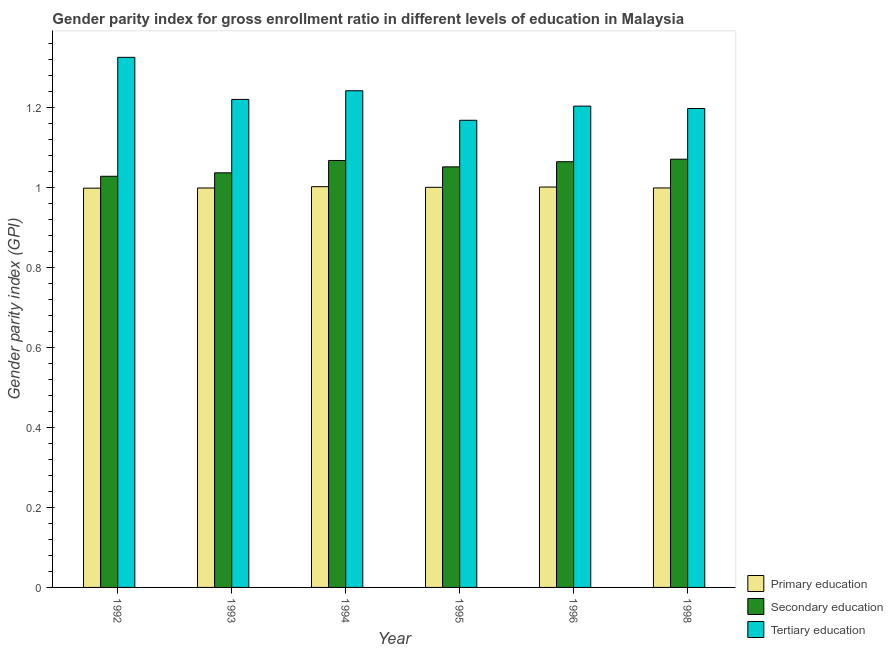How many different coloured bars are there?
Your response must be concise. 3. Are the number of bars per tick equal to the number of legend labels?
Offer a very short reply. Yes. Are the number of bars on each tick of the X-axis equal?
Offer a very short reply. Yes. How many bars are there on the 5th tick from the right?
Your answer should be compact. 3. What is the label of the 5th group of bars from the left?
Make the answer very short. 1996. In how many cases, is the number of bars for a given year not equal to the number of legend labels?
Give a very brief answer. 0. What is the gender parity index in secondary education in 1994?
Give a very brief answer. 1.07. Across all years, what is the maximum gender parity index in tertiary education?
Offer a terse response. 1.33. Across all years, what is the minimum gender parity index in primary education?
Your answer should be very brief. 1. In which year was the gender parity index in secondary education minimum?
Make the answer very short. 1992. What is the total gender parity index in secondary education in the graph?
Your answer should be compact. 6.32. What is the difference between the gender parity index in tertiary education in 1992 and that in 1996?
Your answer should be very brief. 0.12. What is the difference between the gender parity index in primary education in 1998 and the gender parity index in secondary education in 1995?
Your answer should be compact. -0. What is the average gender parity index in tertiary education per year?
Keep it short and to the point. 1.23. In the year 1992, what is the difference between the gender parity index in primary education and gender parity index in secondary education?
Offer a terse response. 0. In how many years, is the gender parity index in primary education greater than 0.8400000000000001?
Offer a terse response. 6. What is the ratio of the gender parity index in secondary education in 1992 to that in 1996?
Give a very brief answer. 0.97. Is the difference between the gender parity index in tertiary education in 1993 and 1995 greater than the difference between the gender parity index in secondary education in 1993 and 1995?
Ensure brevity in your answer.  No. What is the difference between the highest and the second highest gender parity index in secondary education?
Provide a short and direct response. 0. What is the difference between the highest and the lowest gender parity index in tertiary education?
Your answer should be very brief. 0.16. What does the 1st bar from the left in 1998 represents?
Ensure brevity in your answer.  Primary education. What does the 2nd bar from the right in 1994 represents?
Ensure brevity in your answer.  Secondary education. Are all the bars in the graph horizontal?
Offer a terse response. No. How many years are there in the graph?
Your response must be concise. 6. What is the difference between two consecutive major ticks on the Y-axis?
Offer a very short reply. 0.2. Does the graph contain any zero values?
Give a very brief answer. No. Does the graph contain grids?
Your response must be concise. No. Where does the legend appear in the graph?
Provide a short and direct response. Bottom right. How many legend labels are there?
Offer a very short reply. 3. How are the legend labels stacked?
Provide a succinct answer. Vertical. What is the title of the graph?
Provide a short and direct response. Gender parity index for gross enrollment ratio in different levels of education in Malaysia. What is the label or title of the Y-axis?
Your answer should be very brief. Gender parity index (GPI). What is the Gender parity index (GPI) of Primary education in 1992?
Keep it short and to the point. 1. What is the Gender parity index (GPI) in Secondary education in 1992?
Keep it short and to the point. 1.03. What is the Gender parity index (GPI) of Tertiary education in 1992?
Your response must be concise. 1.33. What is the Gender parity index (GPI) of Primary education in 1993?
Your answer should be very brief. 1. What is the Gender parity index (GPI) in Secondary education in 1993?
Provide a succinct answer. 1.04. What is the Gender parity index (GPI) in Tertiary education in 1993?
Your answer should be compact. 1.22. What is the Gender parity index (GPI) in Primary education in 1994?
Your answer should be very brief. 1. What is the Gender parity index (GPI) in Secondary education in 1994?
Make the answer very short. 1.07. What is the Gender parity index (GPI) in Tertiary education in 1994?
Provide a short and direct response. 1.24. What is the Gender parity index (GPI) in Primary education in 1995?
Keep it short and to the point. 1. What is the Gender parity index (GPI) of Secondary education in 1995?
Make the answer very short. 1.05. What is the Gender parity index (GPI) in Tertiary education in 1995?
Offer a very short reply. 1.17. What is the Gender parity index (GPI) in Primary education in 1996?
Offer a terse response. 1. What is the Gender parity index (GPI) in Secondary education in 1996?
Offer a terse response. 1.07. What is the Gender parity index (GPI) in Tertiary education in 1996?
Provide a succinct answer. 1.2. What is the Gender parity index (GPI) of Primary education in 1998?
Provide a succinct answer. 1. What is the Gender parity index (GPI) of Secondary education in 1998?
Give a very brief answer. 1.07. What is the Gender parity index (GPI) in Tertiary education in 1998?
Provide a succinct answer. 1.2. Across all years, what is the maximum Gender parity index (GPI) of Primary education?
Ensure brevity in your answer.  1. Across all years, what is the maximum Gender parity index (GPI) of Secondary education?
Your answer should be compact. 1.07. Across all years, what is the maximum Gender parity index (GPI) of Tertiary education?
Ensure brevity in your answer.  1.33. Across all years, what is the minimum Gender parity index (GPI) of Primary education?
Ensure brevity in your answer.  1. Across all years, what is the minimum Gender parity index (GPI) in Secondary education?
Your answer should be very brief. 1.03. Across all years, what is the minimum Gender parity index (GPI) of Tertiary education?
Provide a succinct answer. 1.17. What is the total Gender parity index (GPI) of Primary education in the graph?
Make the answer very short. 6. What is the total Gender parity index (GPI) in Secondary education in the graph?
Offer a terse response. 6.32. What is the total Gender parity index (GPI) in Tertiary education in the graph?
Your response must be concise. 7.36. What is the difference between the Gender parity index (GPI) in Primary education in 1992 and that in 1993?
Provide a succinct answer. -0. What is the difference between the Gender parity index (GPI) of Secondary education in 1992 and that in 1993?
Offer a very short reply. -0.01. What is the difference between the Gender parity index (GPI) in Tertiary education in 1992 and that in 1993?
Your answer should be very brief. 0.11. What is the difference between the Gender parity index (GPI) in Primary education in 1992 and that in 1994?
Make the answer very short. -0. What is the difference between the Gender parity index (GPI) in Secondary education in 1992 and that in 1994?
Make the answer very short. -0.04. What is the difference between the Gender parity index (GPI) in Tertiary education in 1992 and that in 1994?
Provide a short and direct response. 0.08. What is the difference between the Gender parity index (GPI) of Primary education in 1992 and that in 1995?
Provide a short and direct response. -0. What is the difference between the Gender parity index (GPI) in Secondary education in 1992 and that in 1995?
Provide a succinct answer. -0.02. What is the difference between the Gender parity index (GPI) of Tertiary education in 1992 and that in 1995?
Give a very brief answer. 0.16. What is the difference between the Gender parity index (GPI) in Primary education in 1992 and that in 1996?
Your answer should be very brief. -0. What is the difference between the Gender parity index (GPI) of Secondary education in 1992 and that in 1996?
Make the answer very short. -0.04. What is the difference between the Gender parity index (GPI) of Tertiary education in 1992 and that in 1996?
Keep it short and to the point. 0.12. What is the difference between the Gender parity index (GPI) in Primary education in 1992 and that in 1998?
Keep it short and to the point. -0. What is the difference between the Gender parity index (GPI) in Secondary education in 1992 and that in 1998?
Ensure brevity in your answer.  -0.04. What is the difference between the Gender parity index (GPI) of Tertiary education in 1992 and that in 1998?
Make the answer very short. 0.13. What is the difference between the Gender parity index (GPI) in Primary education in 1993 and that in 1994?
Your answer should be compact. -0. What is the difference between the Gender parity index (GPI) in Secondary education in 1993 and that in 1994?
Provide a succinct answer. -0.03. What is the difference between the Gender parity index (GPI) of Tertiary education in 1993 and that in 1994?
Provide a succinct answer. -0.02. What is the difference between the Gender parity index (GPI) of Primary education in 1993 and that in 1995?
Provide a succinct answer. -0. What is the difference between the Gender parity index (GPI) in Secondary education in 1993 and that in 1995?
Make the answer very short. -0.01. What is the difference between the Gender parity index (GPI) of Tertiary education in 1993 and that in 1995?
Give a very brief answer. 0.05. What is the difference between the Gender parity index (GPI) in Primary education in 1993 and that in 1996?
Give a very brief answer. -0. What is the difference between the Gender parity index (GPI) in Secondary education in 1993 and that in 1996?
Your answer should be very brief. -0.03. What is the difference between the Gender parity index (GPI) of Tertiary education in 1993 and that in 1996?
Your answer should be very brief. 0.02. What is the difference between the Gender parity index (GPI) of Primary education in 1993 and that in 1998?
Your answer should be compact. -0. What is the difference between the Gender parity index (GPI) of Secondary education in 1993 and that in 1998?
Your response must be concise. -0.03. What is the difference between the Gender parity index (GPI) in Tertiary education in 1993 and that in 1998?
Your answer should be very brief. 0.02. What is the difference between the Gender parity index (GPI) in Primary education in 1994 and that in 1995?
Offer a terse response. 0. What is the difference between the Gender parity index (GPI) of Secondary education in 1994 and that in 1995?
Your answer should be compact. 0.02. What is the difference between the Gender parity index (GPI) of Tertiary education in 1994 and that in 1995?
Your answer should be compact. 0.07. What is the difference between the Gender parity index (GPI) of Primary education in 1994 and that in 1996?
Give a very brief answer. 0. What is the difference between the Gender parity index (GPI) in Secondary education in 1994 and that in 1996?
Offer a terse response. 0. What is the difference between the Gender parity index (GPI) in Tertiary education in 1994 and that in 1996?
Keep it short and to the point. 0.04. What is the difference between the Gender parity index (GPI) of Primary education in 1994 and that in 1998?
Provide a short and direct response. 0. What is the difference between the Gender parity index (GPI) of Secondary education in 1994 and that in 1998?
Your answer should be compact. -0. What is the difference between the Gender parity index (GPI) in Tertiary education in 1994 and that in 1998?
Your response must be concise. 0.04. What is the difference between the Gender parity index (GPI) of Primary education in 1995 and that in 1996?
Make the answer very short. -0. What is the difference between the Gender parity index (GPI) in Secondary education in 1995 and that in 1996?
Offer a very short reply. -0.01. What is the difference between the Gender parity index (GPI) in Tertiary education in 1995 and that in 1996?
Ensure brevity in your answer.  -0.04. What is the difference between the Gender parity index (GPI) in Primary education in 1995 and that in 1998?
Offer a terse response. 0. What is the difference between the Gender parity index (GPI) in Secondary education in 1995 and that in 1998?
Offer a terse response. -0.02. What is the difference between the Gender parity index (GPI) of Tertiary education in 1995 and that in 1998?
Your response must be concise. -0.03. What is the difference between the Gender parity index (GPI) of Primary education in 1996 and that in 1998?
Your answer should be very brief. 0. What is the difference between the Gender parity index (GPI) of Secondary education in 1996 and that in 1998?
Offer a terse response. -0.01. What is the difference between the Gender parity index (GPI) of Tertiary education in 1996 and that in 1998?
Ensure brevity in your answer.  0.01. What is the difference between the Gender parity index (GPI) of Primary education in 1992 and the Gender parity index (GPI) of Secondary education in 1993?
Offer a terse response. -0.04. What is the difference between the Gender parity index (GPI) of Primary education in 1992 and the Gender parity index (GPI) of Tertiary education in 1993?
Provide a succinct answer. -0.22. What is the difference between the Gender parity index (GPI) in Secondary education in 1992 and the Gender parity index (GPI) in Tertiary education in 1993?
Offer a very short reply. -0.19. What is the difference between the Gender parity index (GPI) in Primary education in 1992 and the Gender parity index (GPI) in Secondary education in 1994?
Keep it short and to the point. -0.07. What is the difference between the Gender parity index (GPI) in Primary education in 1992 and the Gender parity index (GPI) in Tertiary education in 1994?
Make the answer very short. -0.24. What is the difference between the Gender parity index (GPI) in Secondary education in 1992 and the Gender parity index (GPI) in Tertiary education in 1994?
Offer a very short reply. -0.21. What is the difference between the Gender parity index (GPI) in Primary education in 1992 and the Gender parity index (GPI) in Secondary education in 1995?
Make the answer very short. -0.05. What is the difference between the Gender parity index (GPI) of Primary education in 1992 and the Gender parity index (GPI) of Tertiary education in 1995?
Ensure brevity in your answer.  -0.17. What is the difference between the Gender parity index (GPI) in Secondary education in 1992 and the Gender parity index (GPI) in Tertiary education in 1995?
Make the answer very short. -0.14. What is the difference between the Gender parity index (GPI) of Primary education in 1992 and the Gender parity index (GPI) of Secondary education in 1996?
Give a very brief answer. -0.07. What is the difference between the Gender parity index (GPI) of Primary education in 1992 and the Gender parity index (GPI) of Tertiary education in 1996?
Make the answer very short. -0.21. What is the difference between the Gender parity index (GPI) of Secondary education in 1992 and the Gender parity index (GPI) of Tertiary education in 1996?
Your response must be concise. -0.18. What is the difference between the Gender parity index (GPI) of Primary education in 1992 and the Gender parity index (GPI) of Secondary education in 1998?
Your response must be concise. -0.07. What is the difference between the Gender parity index (GPI) in Primary education in 1992 and the Gender parity index (GPI) in Tertiary education in 1998?
Provide a succinct answer. -0.2. What is the difference between the Gender parity index (GPI) of Secondary education in 1992 and the Gender parity index (GPI) of Tertiary education in 1998?
Give a very brief answer. -0.17. What is the difference between the Gender parity index (GPI) in Primary education in 1993 and the Gender parity index (GPI) in Secondary education in 1994?
Your response must be concise. -0.07. What is the difference between the Gender parity index (GPI) of Primary education in 1993 and the Gender parity index (GPI) of Tertiary education in 1994?
Your answer should be very brief. -0.24. What is the difference between the Gender parity index (GPI) in Secondary education in 1993 and the Gender parity index (GPI) in Tertiary education in 1994?
Give a very brief answer. -0.21. What is the difference between the Gender parity index (GPI) in Primary education in 1993 and the Gender parity index (GPI) in Secondary education in 1995?
Offer a very short reply. -0.05. What is the difference between the Gender parity index (GPI) in Primary education in 1993 and the Gender parity index (GPI) in Tertiary education in 1995?
Your response must be concise. -0.17. What is the difference between the Gender parity index (GPI) of Secondary education in 1993 and the Gender parity index (GPI) of Tertiary education in 1995?
Offer a terse response. -0.13. What is the difference between the Gender parity index (GPI) of Primary education in 1993 and the Gender parity index (GPI) of Secondary education in 1996?
Offer a very short reply. -0.07. What is the difference between the Gender parity index (GPI) in Primary education in 1993 and the Gender parity index (GPI) in Tertiary education in 1996?
Provide a short and direct response. -0.2. What is the difference between the Gender parity index (GPI) in Secondary education in 1993 and the Gender parity index (GPI) in Tertiary education in 1996?
Offer a very short reply. -0.17. What is the difference between the Gender parity index (GPI) in Primary education in 1993 and the Gender parity index (GPI) in Secondary education in 1998?
Offer a very short reply. -0.07. What is the difference between the Gender parity index (GPI) of Primary education in 1993 and the Gender parity index (GPI) of Tertiary education in 1998?
Offer a very short reply. -0.2. What is the difference between the Gender parity index (GPI) of Secondary education in 1993 and the Gender parity index (GPI) of Tertiary education in 1998?
Offer a terse response. -0.16. What is the difference between the Gender parity index (GPI) in Primary education in 1994 and the Gender parity index (GPI) in Secondary education in 1995?
Your response must be concise. -0.05. What is the difference between the Gender parity index (GPI) in Primary education in 1994 and the Gender parity index (GPI) in Tertiary education in 1995?
Provide a succinct answer. -0.17. What is the difference between the Gender parity index (GPI) in Secondary education in 1994 and the Gender parity index (GPI) in Tertiary education in 1995?
Offer a very short reply. -0.1. What is the difference between the Gender parity index (GPI) of Primary education in 1994 and the Gender parity index (GPI) of Secondary education in 1996?
Your response must be concise. -0.06. What is the difference between the Gender parity index (GPI) in Primary education in 1994 and the Gender parity index (GPI) in Tertiary education in 1996?
Make the answer very short. -0.2. What is the difference between the Gender parity index (GPI) of Secondary education in 1994 and the Gender parity index (GPI) of Tertiary education in 1996?
Keep it short and to the point. -0.14. What is the difference between the Gender parity index (GPI) of Primary education in 1994 and the Gender parity index (GPI) of Secondary education in 1998?
Provide a short and direct response. -0.07. What is the difference between the Gender parity index (GPI) of Primary education in 1994 and the Gender parity index (GPI) of Tertiary education in 1998?
Ensure brevity in your answer.  -0.2. What is the difference between the Gender parity index (GPI) in Secondary education in 1994 and the Gender parity index (GPI) in Tertiary education in 1998?
Your response must be concise. -0.13. What is the difference between the Gender parity index (GPI) of Primary education in 1995 and the Gender parity index (GPI) of Secondary education in 1996?
Ensure brevity in your answer.  -0.06. What is the difference between the Gender parity index (GPI) of Primary education in 1995 and the Gender parity index (GPI) of Tertiary education in 1996?
Your answer should be very brief. -0.2. What is the difference between the Gender parity index (GPI) in Secondary education in 1995 and the Gender parity index (GPI) in Tertiary education in 1996?
Offer a terse response. -0.15. What is the difference between the Gender parity index (GPI) in Primary education in 1995 and the Gender parity index (GPI) in Secondary education in 1998?
Keep it short and to the point. -0.07. What is the difference between the Gender parity index (GPI) in Primary education in 1995 and the Gender parity index (GPI) in Tertiary education in 1998?
Ensure brevity in your answer.  -0.2. What is the difference between the Gender parity index (GPI) of Secondary education in 1995 and the Gender parity index (GPI) of Tertiary education in 1998?
Your response must be concise. -0.15. What is the difference between the Gender parity index (GPI) of Primary education in 1996 and the Gender parity index (GPI) of Secondary education in 1998?
Ensure brevity in your answer.  -0.07. What is the difference between the Gender parity index (GPI) in Primary education in 1996 and the Gender parity index (GPI) in Tertiary education in 1998?
Offer a very short reply. -0.2. What is the difference between the Gender parity index (GPI) of Secondary education in 1996 and the Gender parity index (GPI) of Tertiary education in 1998?
Your answer should be compact. -0.13. What is the average Gender parity index (GPI) of Secondary education per year?
Provide a succinct answer. 1.05. What is the average Gender parity index (GPI) of Tertiary education per year?
Keep it short and to the point. 1.23. In the year 1992, what is the difference between the Gender parity index (GPI) of Primary education and Gender parity index (GPI) of Secondary education?
Provide a succinct answer. -0.03. In the year 1992, what is the difference between the Gender parity index (GPI) of Primary education and Gender parity index (GPI) of Tertiary education?
Offer a terse response. -0.33. In the year 1992, what is the difference between the Gender parity index (GPI) of Secondary education and Gender parity index (GPI) of Tertiary education?
Ensure brevity in your answer.  -0.3. In the year 1993, what is the difference between the Gender parity index (GPI) in Primary education and Gender parity index (GPI) in Secondary education?
Provide a short and direct response. -0.04. In the year 1993, what is the difference between the Gender parity index (GPI) in Primary education and Gender parity index (GPI) in Tertiary education?
Provide a succinct answer. -0.22. In the year 1993, what is the difference between the Gender parity index (GPI) of Secondary education and Gender parity index (GPI) of Tertiary education?
Your answer should be compact. -0.18. In the year 1994, what is the difference between the Gender parity index (GPI) in Primary education and Gender parity index (GPI) in Secondary education?
Provide a succinct answer. -0.07. In the year 1994, what is the difference between the Gender parity index (GPI) of Primary education and Gender parity index (GPI) of Tertiary education?
Keep it short and to the point. -0.24. In the year 1994, what is the difference between the Gender parity index (GPI) in Secondary education and Gender parity index (GPI) in Tertiary education?
Make the answer very short. -0.17. In the year 1995, what is the difference between the Gender parity index (GPI) in Primary education and Gender parity index (GPI) in Secondary education?
Provide a short and direct response. -0.05. In the year 1995, what is the difference between the Gender parity index (GPI) in Primary education and Gender parity index (GPI) in Tertiary education?
Your answer should be compact. -0.17. In the year 1995, what is the difference between the Gender parity index (GPI) in Secondary education and Gender parity index (GPI) in Tertiary education?
Provide a short and direct response. -0.12. In the year 1996, what is the difference between the Gender parity index (GPI) in Primary education and Gender parity index (GPI) in Secondary education?
Keep it short and to the point. -0.06. In the year 1996, what is the difference between the Gender parity index (GPI) in Primary education and Gender parity index (GPI) in Tertiary education?
Ensure brevity in your answer.  -0.2. In the year 1996, what is the difference between the Gender parity index (GPI) of Secondary education and Gender parity index (GPI) of Tertiary education?
Offer a terse response. -0.14. In the year 1998, what is the difference between the Gender parity index (GPI) in Primary education and Gender parity index (GPI) in Secondary education?
Offer a very short reply. -0.07. In the year 1998, what is the difference between the Gender parity index (GPI) in Primary education and Gender parity index (GPI) in Tertiary education?
Provide a short and direct response. -0.2. In the year 1998, what is the difference between the Gender parity index (GPI) of Secondary education and Gender parity index (GPI) of Tertiary education?
Your answer should be compact. -0.13. What is the ratio of the Gender parity index (GPI) in Tertiary education in 1992 to that in 1993?
Keep it short and to the point. 1.09. What is the ratio of the Gender parity index (GPI) of Tertiary education in 1992 to that in 1994?
Provide a short and direct response. 1.07. What is the ratio of the Gender parity index (GPI) of Primary education in 1992 to that in 1995?
Your response must be concise. 1. What is the ratio of the Gender parity index (GPI) of Secondary education in 1992 to that in 1995?
Keep it short and to the point. 0.98. What is the ratio of the Gender parity index (GPI) of Tertiary education in 1992 to that in 1995?
Ensure brevity in your answer.  1.13. What is the ratio of the Gender parity index (GPI) of Secondary education in 1992 to that in 1996?
Ensure brevity in your answer.  0.97. What is the ratio of the Gender parity index (GPI) of Tertiary education in 1992 to that in 1996?
Offer a terse response. 1.1. What is the ratio of the Gender parity index (GPI) of Primary education in 1992 to that in 1998?
Your answer should be compact. 1. What is the ratio of the Gender parity index (GPI) in Secondary education in 1992 to that in 1998?
Provide a short and direct response. 0.96. What is the ratio of the Gender parity index (GPI) of Tertiary education in 1992 to that in 1998?
Offer a terse response. 1.11. What is the ratio of the Gender parity index (GPI) in Primary education in 1993 to that in 1994?
Offer a terse response. 1. What is the ratio of the Gender parity index (GPI) of Secondary education in 1993 to that in 1994?
Make the answer very short. 0.97. What is the ratio of the Gender parity index (GPI) of Tertiary education in 1993 to that in 1994?
Offer a very short reply. 0.98. What is the ratio of the Gender parity index (GPI) of Secondary education in 1993 to that in 1995?
Your answer should be very brief. 0.99. What is the ratio of the Gender parity index (GPI) in Tertiary education in 1993 to that in 1995?
Provide a succinct answer. 1.04. What is the ratio of the Gender parity index (GPI) of Primary education in 1993 to that in 1996?
Your response must be concise. 1. What is the ratio of the Gender parity index (GPI) in Secondary education in 1993 to that in 1996?
Make the answer very short. 0.97. What is the ratio of the Gender parity index (GPI) of Tertiary education in 1993 to that in 1996?
Keep it short and to the point. 1.01. What is the ratio of the Gender parity index (GPI) in Secondary education in 1993 to that in 1998?
Your response must be concise. 0.97. What is the ratio of the Gender parity index (GPI) in Secondary education in 1994 to that in 1995?
Your answer should be very brief. 1.02. What is the ratio of the Gender parity index (GPI) in Tertiary education in 1994 to that in 1995?
Your answer should be very brief. 1.06. What is the ratio of the Gender parity index (GPI) of Primary education in 1994 to that in 1996?
Make the answer very short. 1. What is the ratio of the Gender parity index (GPI) of Tertiary education in 1994 to that in 1996?
Offer a terse response. 1.03. What is the ratio of the Gender parity index (GPI) of Primary education in 1994 to that in 1998?
Make the answer very short. 1. What is the ratio of the Gender parity index (GPI) in Secondary education in 1994 to that in 1998?
Your response must be concise. 1. What is the ratio of the Gender parity index (GPI) in Tertiary education in 1994 to that in 1998?
Offer a very short reply. 1.04. What is the ratio of the Gender parity index (GPI) of Primary education in 1995 to that in 1996?
Ensure brevity in your answer.  1. What is the ratio of the Gender parity index (GPI) in Secondary education in 1995 to that in 1996?
Keep it short and to the point. 0.99. What is the ratio of the Gender parity index (GPI) in Tertiary education in 1995 to that in 1996?
Your answer should be very brief. 0.97. What is the ratio of the Gender parity index (GPI) of Secondary education in 1995 to that in 1998?
Your answer should be compact. 0.98. What is the ratio of the Gender parity index (GPI) of Tertiary education in 1995 to that in 1998?
Your answer should be very brief. 0.98. What is the ratio of the Gender parity index (GPI) of Secondary education in 1996 to that in 1998?
Make the answer very short. 0.99. What is the difference between the highest and the second highest Gender parity index (GPI) of Primary education?
Make the answer very short. 0. What is the difference between the highest and the second highest Gender parity index (GPI) of Secondary education?
Your answer should be very brief. 0. What is the difference between the highest and the second highest Gender parity index (GPI) of Tertiary education?
Keep it short and to the point. 0.08. What is the difference between the highest and the lowest Gender parity index (GPI) of Primary education?
Your answer should be very brief. 0. What is the difference between the highest and the lowest Gender parity index (GPI) of Secondary education?
Your answer should be very brief. 0.04. What is the difference between the highest and the lowest Gender parity index (GPI) in Tertiary education?
Keep it short and to the point. 0.16. 